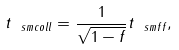Convert formula to latex. <formula><loc_0><loc_0><loc_500><loc_500>t _ { \ s m { c o l l } } = \frac { 1 } { \sqrt { 1 - f } } t _ { \ s m { f f } } ,</formula> 